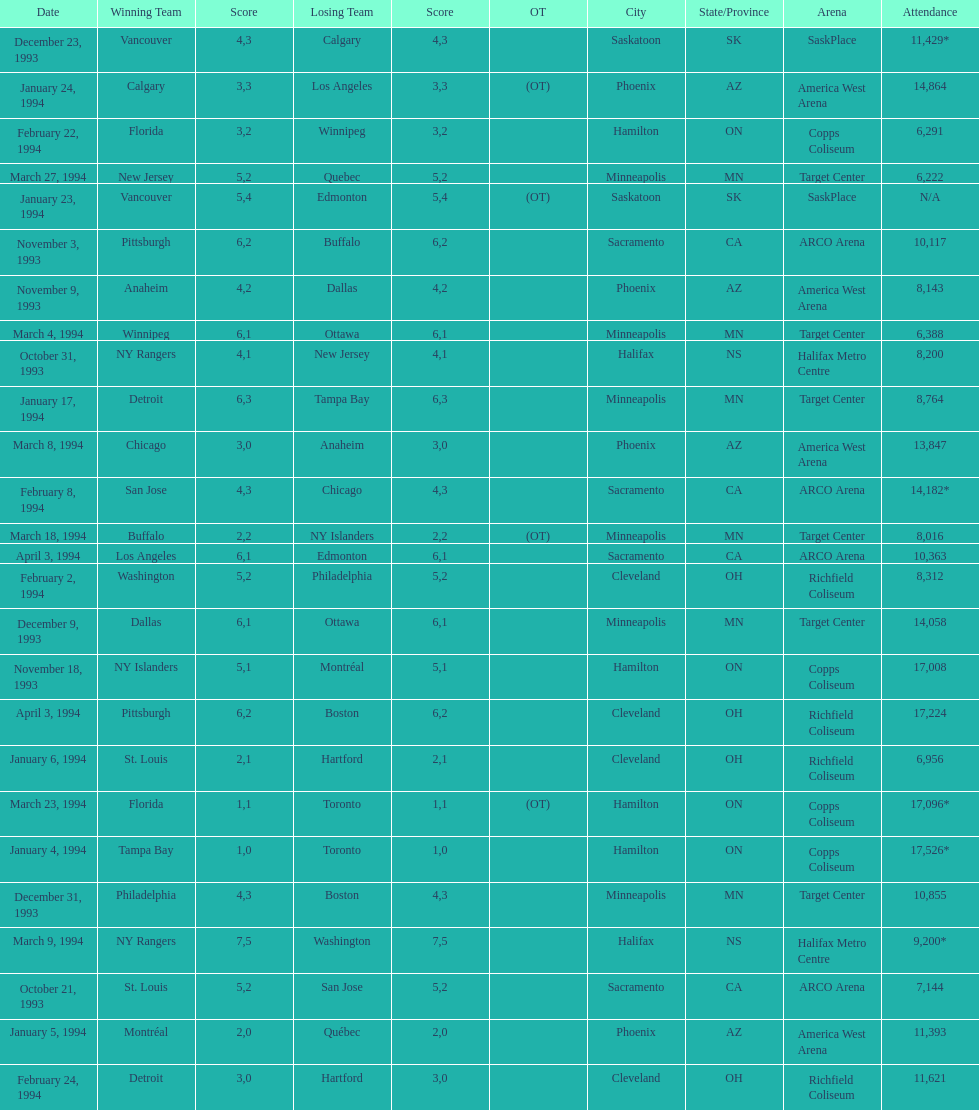The game on which date had the most attendance? January 4, 1994. 